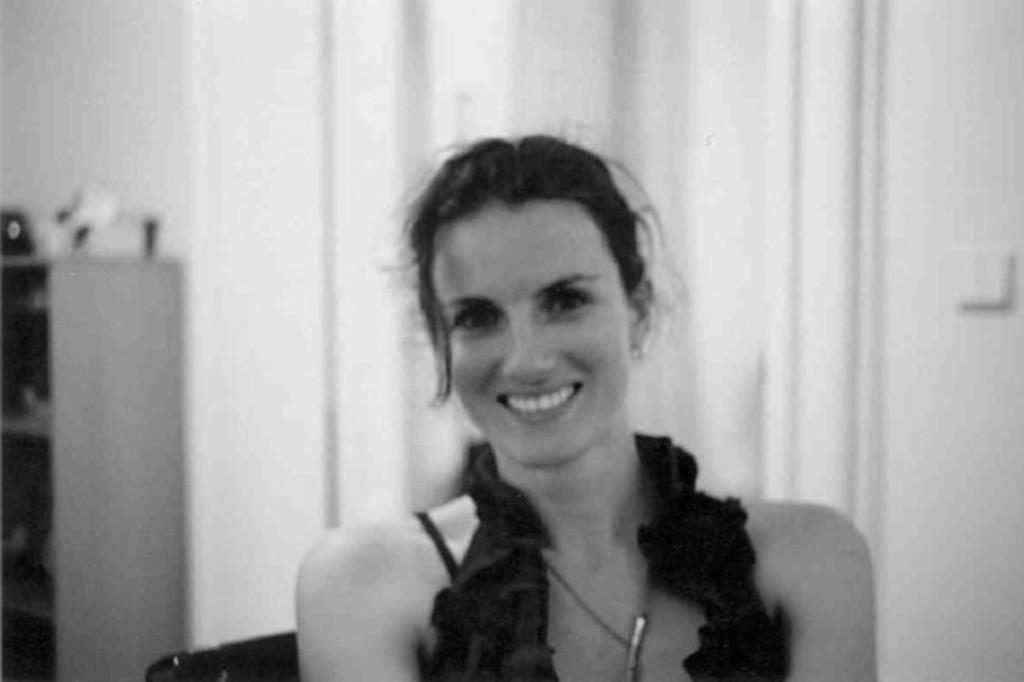What is the color scheme of the image? The image is black and white. Who is present in the image? There is a woman in the image. What is the woman wearing? The woman is wearing a dress. What is the woman's facial expression? The woman is smiling. What can be seen in the background of the image? There is a wall and a cupboard in the background of the image. What is on top of the cupboard? There are items visible on the cupboard. What type of curtain can be seen hanging from the wall in the image? There is no curtain visible in the image; only a wall and a cupboard are present in the background. 